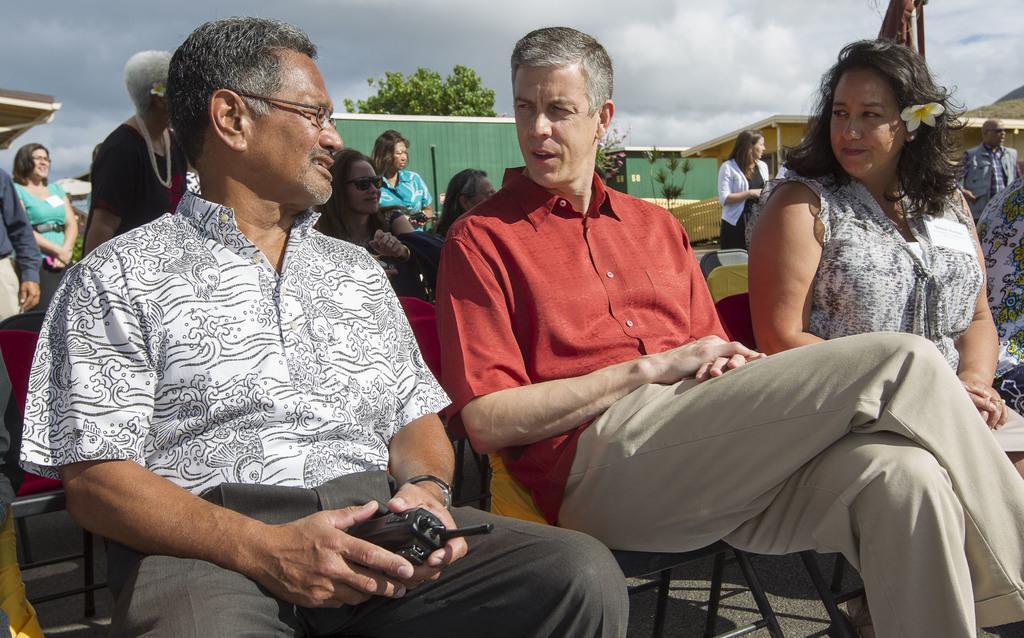Can you describe this image briefly? In this image I can see there are three persons sitting on the chair and background I can see there are group of people and I can see tree and the sky and green color boxes and plants and house visible in the background. 